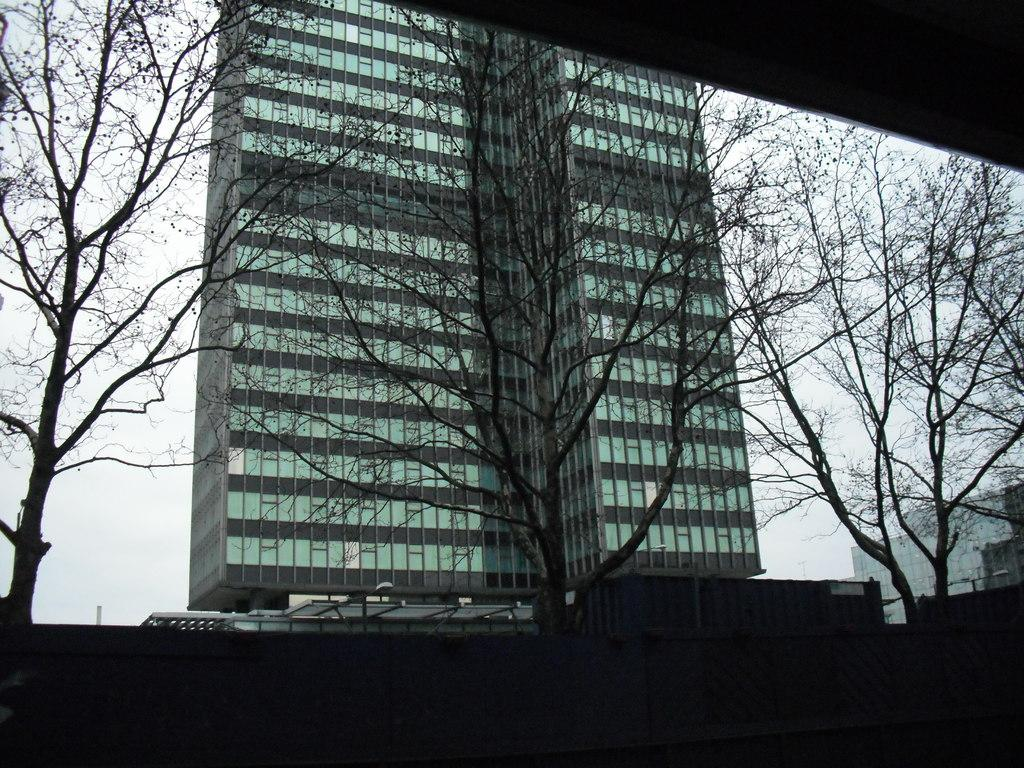What type of vegetation can be seen in the image? There are trees in the image. What is located behind the trees in the image? There are buildings behind the trees in the image. What type of throat condition can be seen in the image? There is no throat condition present in the image; it features trees and buildings. Can you tell me how many kittens are playing with the vegetable in the image? There are no kittens or vegetables present in the image. 